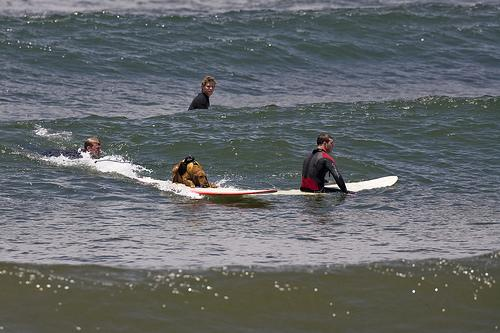Describe the attire and actions of the main human character in the image. A man in a black and red wetsuit is either sitting or lying on a white surfboard with orange edges, facing the right and looking at the camera. Describe the setting in the image, focusing on the water and the participants' positions. Surfers and a dog are positioned amid waves and ripples in the water, with one man submerged neck-deep and the dog skillfully riding a surfboard. Provide a brief description of the most prominent elements in the image. A dog is surfing on a surfboard, while a man in a black and red wetsuit watches nearby. There are ripples in the water and light shining on the surface. Provide a brief overview of the image, highlighting the activities and participants. In the image, three men and a surfing dog are waiting for waves, with one man donning a black and red wetsuit and another man neck-deep in the water. Characterize the image by mentioning the featured canine, the attire of the participants, and the prevalent water conditions. A surfing golden retriever, a man in a black and red wetsuit, and a white surfboard dominate the image, all set against the backdrop of ripples and waves. Mention the type of dog in the image and the accessory it is wearing, along with its activity. A golden retriever is wearing a yellow and black life preserver and is surfing on a red and white surfboard, riding a wave. Discuss the color scheme of the water, surfboards, and wetsuits featured in the image. There's a white surfboard with orange edges and a red and white surfboard, a black and red wetsuit, a yellow and black vest on the dog, and light shining on the water. Narrate the scene in the image, emphasizing the display of skill by the dog. A courageous dog showcases its surfing skills on a surfboard, impressing the onlooking surfers, including a man in a red and black wetsuit. Explain what's happening in the image, focusing on the different activities of the surfers. Surfers are waiting for waves in the water, with one man neck-deep and another sitting on a surfboard, while a dog is actively surfing on a surfboard. Summarize the scene depicted in the image focusing on human and animal interactions. Three men and a large brown dog are in the water, with the dog riding a surfboard and one man wearing a black and red wetsuit looking at the camera. 